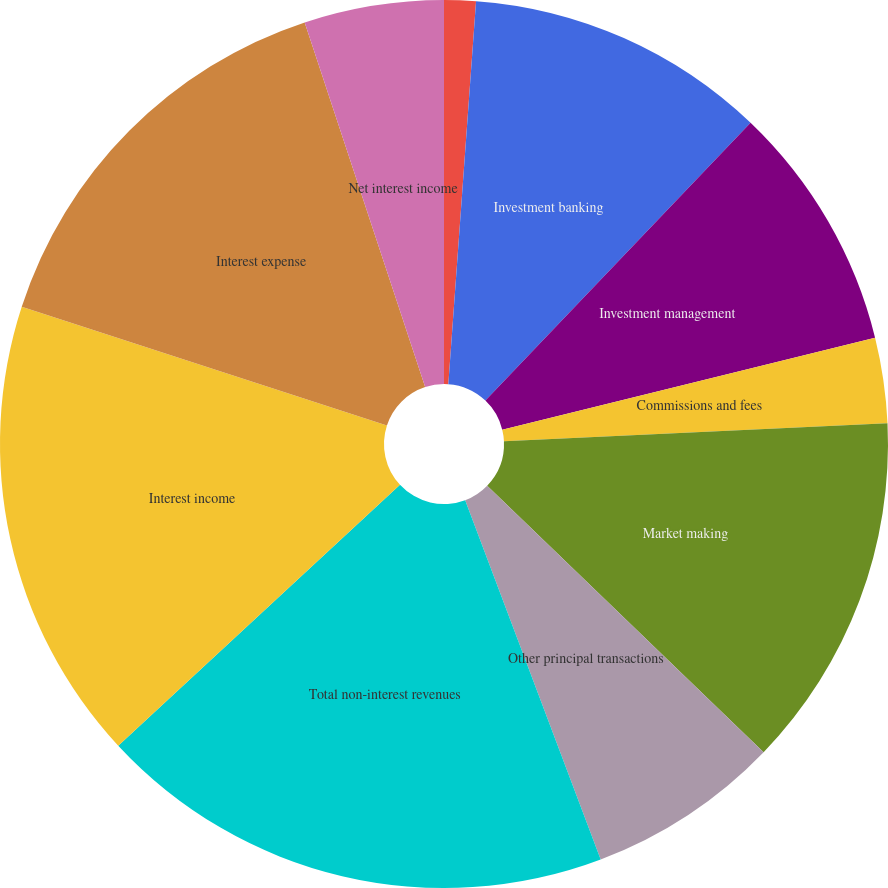Convert chart to OTSL. <chart><loc_0><loc_0><loc_500><loc_500><pie_chart><fcel>in millions<fcel>Investment banking<fcel>Investment management<fcel>Commissions and fees<fcel>Market making<fcel>Other principal transactions<fcel>Total non-interest revenues<fcel>Interest income<fcel>Interest expense<fcel>Net interest income<nl><fcel>1.15%<fcel>10.98%<fcel>9.02%<fcel>3.11%<fcel>12.95%<fcel>7.05%<fcel>18.85%<fcel>16.89%<fcel>14.92%<fcel>5.08%<nl></chart> 